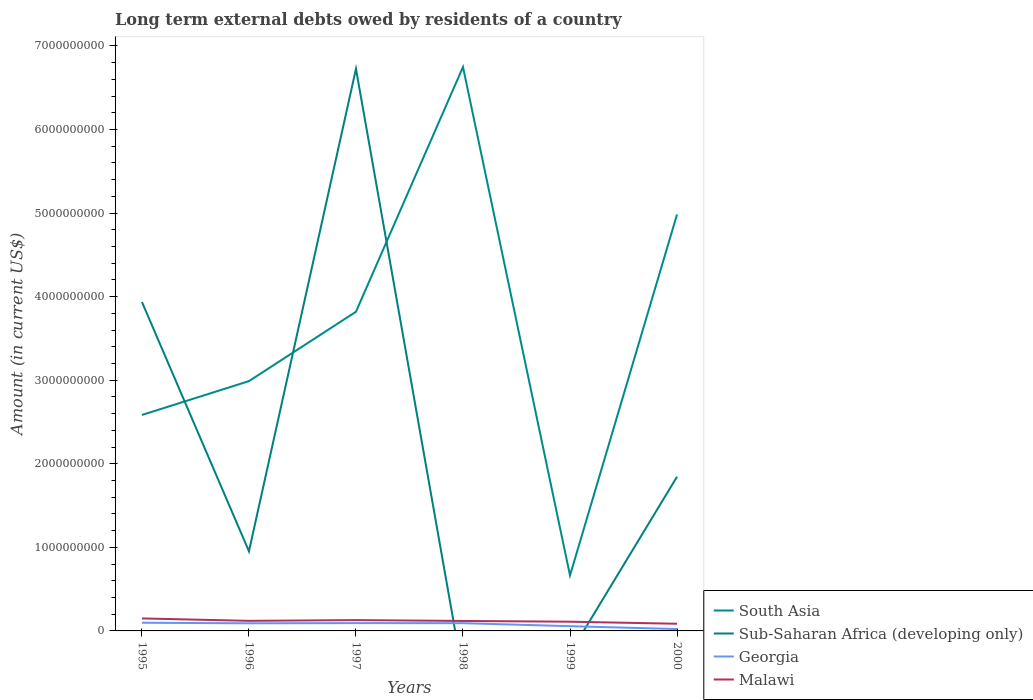How many different coloured lines are there?
Offer a very short reply. 4. Does the line corresponding to Malawi intersect with the line corresponding to Sub-Saharan Africa (developing only)?
Make the answer very short. Yes. Across all years, what is the maximum amount of long-term external debts owed by residents in Malawi?
Ensure brevity in your answer.  8.58e+07. What is the total amount of long-term external debts owed by residents in South Asia in the graph?
Ensure brevity in your answer.  -1.23e+09. What is the difference between the highest and the second highest amount of long-term external debts owed by residents in Georgia?
Your answer should be compact. 7.54e+07. What is the difference between the highest and the lowest amount of long-term external debts owed by residents in Malawi?
Provide a short and direct response. 4. How many lines are there?
Give a very brief answer. 4. How many years are there in the graph?
Give a very brief answer. 6. What is the difference between two consecutive major ticks on the Y-axis?
Your answer should be compact. 1.00e+09. Are the values on the major ticks of Y-axis written in scientific E-notation?
Provide a short and direct response. No. Where does the legend appear in the graph?
Offer a very short reply. Bottom right. How many legend labels are there?
Ensure brevity in your answer.  4. What is the title of the graph?
Keep it short and to the point. Long term external debts owed by residents of a country. What is the label or title of the X-axis?
Provide a succinct answer. Years. What is the label or title of the Y-axis?
Your response must be concise. Amount (in current US$). What is the Amount (in current US$) of South Asia in 1995?
Keep it short and to the point. 2.58e+09. What is the Amount (in current US$) of Sub-Saharan Africa (developing only) in 1995?
Your answer should be very brief. 3.94e+09. What is the Amount (in current US$) of Georgia in 1995?
Make the answer very short. 9.79e+07. What is the Amount (in current US$) in Malawi in 1995?
Your answer should be very brief. 1.50e+08. What is the Amount (in current US$) in South Asia in 1996?
Your response must be concise. 2.99e+09. What is the Amount (in current US$) of Sub-Saharan Africa (developing only) in 1996?
Keep it short and to the point. 9.53e+08. What is the Amount (in current US$) in Georgia in 1996?
Make the answer very short. 9.11e+07. What is the Amount (in current US$) of Malawi in 1996?
Keep it short and to the point. 1.21e+08. What is the Amount (in current US$) in South Asia in 1997?
Make the answer very short. 3.82e+09. What is the Amount (in current US$) of Sub-Saharan Africa (developing only) in 1997?
Keep it short and to the point. 6.73e+09. What is the Amount (in current US$) in Georgia in 1997?
Give a very brief answer. 9.36e+07. What is the Amount (in current US$) in Malawi in 1997?
Provide a succinct answer. 1.30e+08. What is the Amount (in current US$) in South Asia in 1998?
Give a very brief answer. 6.75e+09. What is the Amount (in current US$) of Sub-Saharan Africa (developing only) in 1998?
Keep it short and to the point. 0. What is the Amount (in current US$) in Georgia in 1998?
Provide a short and direct response. 9.25e+07. What is the Amount (in current US$) of Malawi in 1998?
Offer a very short reply. 1.19e+08. What is the Amount (in current US$) in South Asia in 1999?
Provide a short and direct response. 6.64e+08. What is the Amount (in current US$) in Georgia in 1999?
Provide a succinct answer. 5.68e+07. What is the Amount (in current US$) of Malawi in 1999?
Make the answer very short. 1.10e+08. What is the Amount (in current US$) in South Asia in 2000?
Provide a short and direct response. 4.98e+09. What is the Amount (in current US$) in Sub-Saharan Africa (developing only) in 2000?
Provide a succinct answer. 1.84e+09. What is the Amount (in current US$) of Georgia in 2000?
Make the answer very short. 2.25e+07. What is the Amount (in current US$) of Malawi in 2000?
Make the answer very short. 8.58e+07. Across all years, what is the maximum Amount (in current US$) of South Asia?
Ensure brevity in your answer.  6.75e+09. Across all years, what is the maximum Amount (in current US$) of Sub-Saharan Africa (developing only)?
Your response must be concise. 6.73e+09. Across all years, what is the maximum Amount (in current US$) in Georgia?
Make the answer very short. 9.79e+07. Across all years, what is the maximum Amount (in current US$) in Malawi?
Offer a terse response. 1.50e+08. Across all years, what is the minimum Amount (in current US$) in South Asia?
Offer a terse response. 6.64e+08. Across all years, what is the minimum Amount (in current US$) in Sub-Saharan Africa (developing only)?
Ensure brevity in your answer.  0. Across all years, what is the minimum Amount (in current US$) in Georgia?
Your response must be concise. 2.25e+07. Across all years, what is the minimum Amount (in current US$) of Malawi?
Provide a succinct answer. 8.58e+07. What is the total Amount (in current US$) of South Asia in the graph?
Ensure brevity in your answer.  2.18e+1. What is the total Amount (in current US$) of Sub-Saharan Africa (developing only) in the graph?
Provide a succinct answer. 1.35e+1. What is the total Amount (in current US$) in Georgia in the graph?
Keep it short and to the point. 4.54e+08. What is the total Amount (in current US$) in Malawi in the graph?
Offer a very short reply. 7.15e+08. What is the difference between the Amount (in current US$) of South Asia in 1995 and that in 1996?
Make the answer very short. -4.05e+08. What is the difference between the Amount (in current US$) of Sub-Saharan Africa (developing only) in 1995 and that in 1996?
Offer a very short reply. 2.98e+09. What is the difference between the Amount (in current US$) of Georgia in 1995 and that in 1996?
Provide a short and direct response. 6.79e+06. What is the difference between the Amount (in current US$) in Malawi in 1995 and that in 1996?
Offer a terse response. 2.90e+07. What is the difference between the Amount (in current US$) in South Asia in 1995 and that in 1997?
Provide a succinct answer. -1.23e+09. What is the difference between the Amount (in current US$) of Sub-Saharan Africa (developing only) in 1995 and that in 1997?
Give a very brief answer. -2.79e+09. What is the difference between the Amount (in current US$) in Georgia in 1995 and that in 1997?
Provide a short and direct response. 4.30e+06. What is the difference between the Amount (in current US$) of Malawi in 1995 and that in 1997?
Make the answer very short. 2.00e+07. What is the difference between the Amount (in current US$) of South Asia in 1995 and that in 1998?
Give a very brief answer. -4.16e+09. What is the difference between the Amount (in current US$) of Georgia in 1995 and that in 1998?
Keep it short and to the point. 5.34e+06. What is the difference between the Amount (in current US$) of Malawi in 1995 and that in 1998?
Give a very brief answer. 3.04e+07. What is the difference between the Amount (in current US$) of South Asia in 1995 and that in 1999?
Offer a terse response. 1.92e+09. What is the difference between the Amount (in current US$) of Georgia in 1995 and that in 1999?
Your answer should be very brief. 4.11e+07. What is the difference between the Amount (in current US$) in Malawi in 1995 and that in 1999?
Provide a succinct answer. 3.93e+07. What is the difference between the Amount (in current US$) of South Asia in 1995 and that in 2000?
Keep it short and to the point. -2.40e+09. What is the difference between the Amount (in current US$) of Sub-Saharan Africa (developing only) in 1995 and that in 2000?
Provide a short and direct response. 2.09e+09. What is the difference between the Amount (in current US$) in Georgia in 1995 and that in 2000?
Your answer should be very brief. 7.54e+07. What is the difference between the Amount (in current US$) in Malawi in 1995 and that in 2000?
Your response must be concise. 6.38e+07. What is the difference between the Amount (in current US$) of South Asia in 1996 and that in 1997?
Make the answer very short. -8.30e+08. What is the difference between the Amount (in current US$) of Sub-Saharan Africa (developing only) in 1996 and that in 1997?
Your answer should be very brief. -5.77e+09. What is the difference between the Amount (in current US$) in Georgia in 1996 and that in 1997?
Your answer should be compact. -2.48e+06. What is the difference between the Amount (in current US$) of Malawi in 1996 and that in 1997?
Your answer should be compact. -8.96e+06. What is the difference between the Amount (in current US$) of South Asia in 1996 and that in 1998?
Provide a short and direct response. -3.76e+09. What is the difference between the Amount (in current US$) of Georgia in 1996 and that in 1998?
Make the answer very short. -1.45e+06. What is the difference between the Amount (in current US$) of Malawi in 1996 and that in 1998?
Your answer should be very brief. 1.41e+06. What is the difference between the Amount (in current US$) of South Asia in 1996 and that in 1999?
Give a very brief answer. 2.33e+09. What is the difference between the Amount (in current US$) in Georgia in 1996 and that in 1999?
Offer a terse response. 3.43e+07. What is the difference between the Amount (in current US$) in Malawi in 1996 and that in 1999?
Offer a terse response. 1.03e+07. What is the difference between the Amount (in current US$) in South Asia in 1996 and that in 2000?
Provide a succinct answer. -1.99e+09. What is the difference between the Amount (in current US$) in Sub-Saharan Africa (developing only) in 1996 and that in 2000?
Offer a terse response. -8.92e+08. What is the difference between the Amount (in current US$) in Georgia in 1996 and that in 2000?
Your response must be concise. 6.86e+07. What is the difference between the Amount (in current US$) of Malawi in 1996 and that in 2000?
Provide a short and direct response. 3.48e+07. What is the difference between the Amount (in current US$) of South Asia in 1997 and that in 1998?
Your answer should be very brief. -2.93e+09. What is the difference between the Amount (in current US$) of Georgia in 1997 and that in 1998?
Your answer should be compact. 1.04e+06. What is the difference between the Amount (in current US$) in Malawi in 1997 and that in 1998?
Ensure brevity in your answer.  1.04e+07. What is the difference between the Amount (in current US$) in South Asia in 1997 and that in 1999?
Give a very brief answer. 3.16e+09. What is the difference between the Amount (in current US$) of Georgia in 1997 and that in 1999?
Keep it short and to the point. 3.68e+07. What is the difference between the Amount (in current US$) of Malawi in 1997 and that in 1999?
Provide a short and direct response. 1.93e+07. What is the difference between the Amount (in current US$) in South Asia in 1997 and that in 2000?
Offer a very short reply. -1.16e+09. What is the difference between the Amount (in current US$) of Sub-Saharan Africa (developing only) in 1997 and that in 2000?
Provide a short and direct response. 4.88e+09. What is the difference between the Amount (in current US$) in Georgia in 1997 and that in 2000?
Your answer should be compact. 7.11e+07. What is the difference between the Amount (in current US$) in Malawi in 1997 and that in 2000?
Provide a succinct answer. 4.38e+07. What is the difference between the Amount (in current US$) of South Asia in 1998 and that in 1999?
Provide a short and direct response. 6.08e+09. What is the difference between the Amount (in current US$) in Georgia in 1998 and that in 1999?
Your response must be concise. 3.58e+07. What is the difference between the Amount (in current US$) of Malawi in 1998 and that in 1999?
Offer a very short reply. 8.88e+06. What is the difference between the Amount (in current US$) in South Asia in 1998 and that in 2000?
Your answer should be very brief. 1.76e+09. What is the difference between the Amount (in current US$) of Georgia in 1998 and that in 2000?
Your answer should be compact. 7.00e+07. What is the difference between the Amount (in current US$) in Malawi in 1998 and that in 2000?
Your response must be concise. 3.34e+07. What is the difference between the Amount (in current US$) of South Asia in 1999 and that in 2000?
Your answer should be very brief. -4.32e+09. What is the difference between the Amount (in current US$) in Georgia in 1999 and that in 2000?
Your answer should be very brief. 3.43e+07. What is the difference between the Amount (in current US$) of Malawi in 1999 and that in 2000?
Your response must be concise. 2.46e+07. What is the difference between the Amount (in current US$) in South Asia in 1995 and the Amount (in current US$) in Sub-Saharan Africa (developing only) in 1996?
Make the answer very short. 1.63e+09. What is the difference between the Amount (in current US$) of South Asia in 1995 and the Amount (in current US$) of Georgia in 1996?
Offer a terse response. 2.49e+09. What is the difference between the Amount (in current US$) of South Asia in 1995 and the Amount (in current US$) of Malawi in 1996?
Make the answer very short. 2.46e+09. What is the difference between the Amount (in current US$) in Sub-Saharan Africa (developing only) in 1995 and the Amount (in current US$) in Georgia in 1996?
Provide a succinct answer. 3.85e+09. What is the difference between the Amount (in current US$) of Sub-Saharan Africa (developing only) in 1995 and the Amount (in current US$) of Malawi in 1996?
Offer a terse response. 3.82e+09. What is the difference between the Amount (in current US$) in Georgia in 1995 and the Amount (in current US$) in Malawi in 1996?
Provide a short and direct response. -2.28e+07. What is the difference between the Amount (in current US$) in South Asia in 1995 and the Amount (in current US$) in Sub-Saharan Africa (developing only) in 1997?
Offer a very short reply. -4.14e+09. What is the difference between the Amount (in current US$) of South Asia in 1995 and the Amount (in current US$) of Georgia in 1997?
Your response must be concise. 2.49e+09. What is the difference between the Amount (in current US$) of South Asia in 1995 and the Amount (in current US$) of Malawi in 1997?
Keep it short and to the point. 2.45e+09. What is the difference between the Amount (in current US$) of Sub-Saharan Africa (developing only) in 1995 and the Amount (in current US$) of Georgia in 1997?
Offer a very short reply. 3.84e+09. What is the difference between the Amount (in current US$) in Sub-Saharan Africa (developing only) in 1995 and the Amount (in current US$) in Malawi in 1997?
Your answer should be compact. 3.81e+09. What is the difference between the Amount (in current US$) in Georgia in 1995 and the Amount (in current US$) in Malawi in 1997?
Keep it short and to the point. -3.17e+07. What is the difference between the Amount (in current US$) in South Asia in 1995 and the Amount (in current US$) in Georgia in 1998?
Provide a short and direct response. 2.49e+09. What is the difference between the Amount (in current US$) in South Asia in 1995 and the Amount (in current US$) in Malawi in 1998?
Ensure brevity in your answer.  2.46e+09. What is the difference between the Amount (in current US$) in Sub-Saharan Africa (developing only) in 1995 and the Amount (in current US$) in Georgia in 1998?
Make the answer very short. 3.84e+09. What is the difference between the Amount (in current US$) in Sub-Saharan Africa (developing only) in 1995 and the Amount (in current US$) in Malawi in 1998?
Ensure brevity in your answer.  3.82e+09. What is the difference between the Amount (in current US$) in Georgia in 1995 and the Amount (in current US$) in Malawi in 1998?
Provide a succinct answer. -2.14e+07. What is the difference between the Amount (in current US$) in South Asia in 1995 and the Amount (in current US$) in Georgia in 1999?
Provide a succinct answer. 2.53e+09. What is the difference between the Amount (in current US$) in South Asia in 1995 and the Amount (in current US$) in Malawi in 1999?
Your answer should be compact. 2.47e+09. What is the difference between the Amount (in current US$) in Sub-Saharan Africa (developing only) in 1995 and the Amount (in current US$) in Georgia in 1999?
Provide a short and direct response. 3.88e+09. What is the difference between the Amount (in current US$) of Sub-Saharan Africa (developing only) in 1995 and the Amount (in current US$) of Malawi in 1999?
Offer a terse response. 3.83e+09. What is the difference between the Amount (in current US$) in Georgia in 1995 and the Amount (in current US$) in Malawi in 1999?
Provide a succinct answer. -1.25e+07. What is the difference between the Amount (in current US$) of South Asia in 1995 and the Amount (in current US$) of Sub-Saharan Africa (developing only) in 2000?
Keep it short and to the point. 7.39e+08. What is the difference between the Amount (in current US$) of South Asia in 1995 and the Amount (in current US$) of Georgia in 2000?
Offer a very short reply. 2.56e+09. What is the difference between the Amount (in current US$) in South Asia in 1995 and the Amount (in current US$) in Malawi in 2000?
Keep it short and to the point. 2.50e+09. What is the difference between the Amount (in current US$) in Sub-Saharan Africa (developing only) in 1995 and the Amount (in current US$) in Georgia in 2000?
Make the answer very short. 3.91e+09. What is the difference between the Amount (in current US$) of Sub-Saharan Africa (developing only) in 1995 and the Amount (in current US$) of Malawi in 2000?
Give a very brief answer. 3.85e+09. What is the difference between the Amount (in current US$) of Georgia in 1995 and the Amount (in current US$) of Malawi in 2000?
Keep it short and to the point. 1.21e+07. What is the difference between the Amount (in current US$) in South Asia in 1996 and the Amount (in current US$) in Sub-Saharan Africa (developing only) in 1997?
Provide a succinct answer. -3.74e+09. What is the difference between the Amount (in current US$) in South Asia in 1996 and the Amount (in current US$) in Georgia in 1997?
Ensure brevity in your answer.  2.90e+09. What is the difference between the Amount (in current US$) of South Asia in 1996 and the Amount (in current US$) of Malawi in 1997?
Provide a succinct answer. 2.86e+09. What is the difference between the Amount (in current US$) in Sub-Saharan Africa (developing only) in 1996 and the Amount (in current US$) in Georgia in 1997?
Provide a succinct answer. 8.59e+08. What is the difference between the Amount (in current US$) of Sub-Saharan Africa (developing only) in 1996 and the Amount (in current US$) of Malawi in 1997?
Offer a very short reply. 8.23e+08. What is the difference between the Amount (in current US$) of Georgia in 1996 and the Amount (in current US$) of Malawi in 1997?
Offer a terse response. -3.85e+07. What is the difference between the Amount (in current US$) in South Asia in 1996 and the Amount (in current US$) in Georgia in 1998?
Your answer should be very brief. 2.90e+09. What is the difference between the Amount (in current US$) of South Asia in 1996 and the Amount (in current US$) of Malawi in 1998?
Your response must be concise. 2.87e+09. What is the difference between the Amount (in current US$) of Sub-Saharan Africa (developing only) in 1996 and the Amount (in current US$) of Georgia in 1998?
Make the answer very short. 8.60e+08. What is the difference between the Amount (in current US$) in Sub-Saharan Africa (developing only) in 1996 and the Amount (in current US$) in Malawi in 1998?
Give a very brief answer. 8.34e+08. What is the difference between the Amount (in current US$) in Georgia in 1996 and the Amount (in current US$) in Malawi in 1998?
Offer a terse response. -2.82e+07. What is the difference between the Amount (in current US$) of South Asia in 1996 and the Amount (in current US$) of Georgia in 1999?
Ensure brevity in your answer.  2.93e+09. What is the difference between the Amount (in current US$) in South Asia in 1996 and the Amount (in current US$) in Malawi in 1999?
Give a very brief answer. 2.88e+09. What is the difference between the Amount (in current US$) of Sub-Saharan Africa (developing only) in 1996 and the Amount (in current US$) of Georgia in 1999?
Ensure brevity in your answer.  8.96e+08. What is the difference between the Amount (in current US$) of Sub-Saharan Africa (developing only) in 1996 and the Amount (in current US$) of Malawi in 1999?
Give a very brief answer. 8.43e+08. What is the difference between the Amount (in current US$) in Georgia in 1996 and the Amount (in current US$) in Malawi in 1999?
Your answer should be compact. -1.93e+07. What is the difference between the Amount (in current US$) in South Asia in 1996 and the Amount (in current US$) in Sub-Saharan Africa (developing only) in 2000?
Keep it short and to the point. 1.14e+09. What is the difference between the Amount (in current US$) in South Asia in 1996 and the Amount (in current US$) in Georgia in 2000?
Give a very brief answer. 2.97e+09. What is the difference between the Amount (in current US$) in South Asia in 1996 and the Amount (in current US$) in Malawi in 2000?
Provide a short and direct response. 2.90e+09. What is the difference between the Amount (in current US$) in Sub-Saharan Africa (developing only) in 1996 and the Amount (in current US$) in Georgia in 2000?
Offer a very short reply. 9.30e+08. What is the difference between the Amount (in current US$) in Sub-Saharan Africa (developing only) in 1996 and the Amount (in current US$) in Malawi in 2000?
Ensure brevity in your answer.  8.67e+08. What is the difference between the Amount (in current US$) of Georgia in 1996 and the Amount (in current US$) of Malawi in 2000?
Your answer should be very brief. 5.28e+06. What is the difference between the Amount (in current US$) of South Asia in 1997 and the Amount (in current US$) of Georgia in 1998?
Your answer should be very brief. 3.73e+09. What is the difference between the Amount (in current US$) in South Asia in 1997 and the Amount (in current US$) in Malawi in 1998?
Give a very brief answer. 3.70e+09. What is the difference between the Amount (in current US$) of Sub-Saharan Africa (developing only) in 1997 and the Amount (in current US$) of Georgia in 1998?
Your response must be concise. 6.63e+09. What is the difference between the Amount (in current US$) in Sub-Saharan Africa (developing only) in 1997 and the Amount (in current US$) in Malawi in 1998?
Your answer should be compact. 6.61e+09. What is the difference between the Amount (in current US$) in Georgia in 1997 and the Amount (in current US$) in Malawi in 1998?
Your answer should be compact. -2.57e+07. What is the difference between the Amount (in current US$) in South Asia in 1997 and the Amount (in current US$) in Georgia in 1999?
Give a very brief answer. 3.76e+09. What is the difference between the Amount (in current US$) in South Asia in 1997 and the Amount (in current US$) in Malawi in 1999?
Keep it short and to the point. 3.71e+09. What is the difference between the Amount (in current US$) of Sub-Saharan Africa (developing only) in 1997 and the Amount (in current US$) of Georgia in 1999?
Give a very brief answer. 6.67e+09. What is the difference between the Amount (in current US$) in Sub-Saharan Africa (developing only) in 1997 and the Amount (in current US$) in Malawi in 1999?
Provide a short and direct response. 6.62e+09. What is the difference between the Amount (in current US$) of Georgia in 1997 and the Amount (in current US$) of Malawi in 1999?
Provide a short and direct response. -1.68e+07. What is the difference between the Amount (in current US$) of South Asia in 1997 and the Amount (in current US$) of Sub-Saharan Africa (developing only) in 2000?
Your response must be concise. 1.97e+09. What is the difference between the Amount (in current US$) of South Asia in 1997 and the Amount (in current US$) of Georgia in 2000?
Offer a very short reply. 3.80e+09. What is the difference between the Amount (in current US$) in South Asia in 1997 and the Amount (in current US$) in Malawi in 2000?
Your response must be concise. 3.73e+09. What is the difference between the Amount (in current US$) in Sub-Saharan Africa (developing only) in 1997 and the Amount (in current US$) in Georgia in 2000?
Offer a terse response. 6.70e+09. What is the difference between the Amount (in current US$) of Sub-Saharan Africa (developing only) in 1997 and the Amount (in current US$) of Malawi in 2000?
Give a very brief answer. 6.64e+09. What is the difference between the Amount (in current US$) of Georgia in 1997 and the Amount (in current US$) of Malawi in 2000?
Ensure brevity in your answer.  7.76e+06. What is the difference between the Amount (in current US$) of South Asia in 1998 and the Amount (in current US$) of Georgia in 1999?
Provide a short and direct response. 6.69e+09. What is the difference between the Amount (in current US$) in South Asia in 1998 and the Amount (in current US$) in Malawi in 1999?
Give a very brief answer. 6.64e+09. What is the difference between the Amount (in current US$) of Georgia in 1998 and the Amount (in current US$) of Malawi in 1999?
Your answer should be very brief. -1.78e+07. What is the difference between the Amount (in current US$) in South Asia in 1998 and the Amount (in current US$) in Sub-Saharan Africa (developing only) in 2000?
Give a very brief answer. 4.90e+09. What is the difference between the Amount (in current US$) in South Asia in 1998 and the Amount (in current US$) in Georgia in 2000?
Ensure brevity in your answer.  6.73e+09. What is the difference between the Amount (in current US$) in South Asia in 1998 and the Amount (in current US$) in Malawi in 2000?
Provide a short and direct response. 6.66e+09. What is the difference between the Amount (in current US$) in Georgia in 1998 and the Amount (in current US$) in Malawi in 2000?
Your response must be concise. 6.72e+06. What is the difference between the Amount (in current US$) in South Asia in 1999 and the Amount (in current US$) in Sub-Saharan Africa (developing only) in 2000?
Keep it short and to the point. -1.18e+09. What is the difference between the Amount (in current US$) in South Asia in 1999 and the Amount (in current US$) in Georgia in 2000?
Your response must be concise. 6.41e+08. What is the difference between the Amount (in current US$) in South Asia in 1999 and the Amount (in current US$) in Malawi in 2000?
Provide a succinct answer. 5.78e+08. What is the difference between the Amount (in current US$) in Georgia in 1999 and the Amount (in current US$) in Malawi in 2000?
Keep it short and to the point. -2.90e+07. What is the average Amount (in current US$) in South Asia per year?
Offer a very short reply. 3.63e+09. What is the average Amount (in current US$) in Sub-Saharan Africa (developing only) per year?
Your answer should be compact. 2.24e+09. What is the average Amount (in current US$) in Georgia per year?
Your response must be concise. 7.57e+07. What is the average Amount (in current US$) of Malawi per year?
Give a very brief answer. 1.19e+08. In the year 1995, what is the difference between the Amount (in current US$) in South Asia and Amount (in current US$) in Sub-Saharan Africa (developing only)?
Your answer should be very brief. -1.35e+09. In the year 1995, what is the difference between the Amount (in current US$) of South Asia and Amount (in current US$) of Georgia?
Offer a very short reply. 2.49e+09. In the year 1995, what is the difference between the Amount (in current US$) of South Asia and Amount (in current US$) of Malawi?
Keep it short and to the point. 2.43e+09. In the year 1995, what is the difference between the Amount (in current US$) of Sub-Saharan Africa (developing only) and Amount (in current US$) of Georgia?
Your answer should be compact. 3.84e+09. In the year 1995, what is the difference between the Amount (in current US$) of Sub-Saharan Africa (developing only) and Amount (in current US$) of Malawi?
Provide a succinct answer. 3.79e+09. In the year 1995, what is the difference between the Amount (in current US$) in Georgia and Amount (in current US$) in Malawi?
Your answer should be compact. -5.18e+07. In the year 1996, what is the difference between the Amount (in current US$) in South Asia and Amount (in current US$) in Sub-Saharan Africa (developing only)?
Make the answer very short. 2.04e+09. In the year 1996, what is the difference between the Amount (in current US$) of South Asia and Amount (in current US$) of Georgia?
Ensure brevity in your answer.  2.90e+09. In the year 1996, what is the difference between the Amount (in current US$) in South Asia and Amount (in current US$) in Malawi?
Your response must be concise. 2.87e+09. In the year 1996, what is the difference between the Amount (in current US$) in Sub-Saharan Africa (developing only) and Amount (in current US$) in Georgia?
Your answer should be very brief. 8.62e+08. In the year 1996, what is the difference between the Amount (in current US$) in Sub-Saharan Africa (developing only) and Amount (in current US$) in Malawi?
Offer a terse response. 8.32e+08. In the year 1996, what is the difference between the Amount (in current US$) in Georgia and Amount (in current US$) in Malawi?
Offer a terse response. -2.96e+07. In the year 1997, what is the difference between the Amount (in current US$) of South Asia and Amount (in current US$) of Sub-Saharan Africa (developing only)?
Offer a very short reply. -2.91e+09. In the year 1997, what is the difference between the Amount (in current US$) of South Asia and Amount (in current US$) of Georgia?
Keep it short and to the point. 3.73e+09. In the year 1997, what is the difference between the Amount (in current US$) in South Asia and Amount (in current US$) in Malawi?
Your response must be concise. 3.69e+09. In the year 1997, what is the difference between the Amount (in current US$) in Sub-Saharan Africa (developing only) and Amount (in current US$) in Georgia?
Your answer should be compact. 6.63e+09. In the year 1997, what is the difference between the Amount (in current US$) in Sub-Saharan Africa (developing only) and Amount (in current US$) in Malawi?
Keep it short and to the point. 6.60e+09. In the year 1997, what is the difference between the Amount (in current US$) of Georgia and Amount (in current US$) of Malawi?
Ensure brevity in your answer.  -3.60e+07. In the year 1998, what is the difference between the Amount (in current US$) in South Asia and Amount (in current US$) in Georgia?
Your answer should be very brief. 6.66e+09. In the year 1998, what is the difference between the Amount (in current US$) of South Asia and Amount (in current US$) of Malawi?
Ensure brevity in your answer.  6.63e+09. In the year 1998, what is the difference between the Amount (in current US$) of Georgia and Amount (in current US$) of Malawi?
Provide a short and direct response. -2.67e+07. In the year 1999, what is the difference between the Amount (in current US$) of South Asia and Amount (in current US$) of Georgia?
Ensure brevity in your answer.  6.07e+08. In the year 1999, what is the difference between the Amount (in current US$) in South Asia and Amount (in current US$) in Malawi?
Keep it short and to the point. 5.53e+08. In the year 1999, what is the difference between the Amount (in current US$) in Georgia and Amount (in current US$) in Malawi?
Give a very brief answer. -5.36e+07. In the year 2000, what is the difference between the Amount (in current US$) of South Asia and Amount (in current US$) of Sub-Saharan Africa (developing only)?
Keep it short and to the point. 3.14e+09. In the year 2000, what is the difference between the Amount (in current US$) of South Asia and Amount (in current US$) of Georgia?
Give a very brief answer. 4.96e+09. In the year 2000, what is the difference between the Amount (in current US$) in South Asia and Amount (in current US$) in Malawi?
Make the answer very short. 4.90e+09. In the year 2000, what is the difference between the Amount (in current US$) of Sub-Saharan Africa (developing only) and Amount (in current US$) of Georgia?
Your response must be concise. 1.82e+09. In the year 2000, what is the difference between the Amount (in current US$) of Sub-Saharan Africa (developing only) and Amount (in current US$) of Malawi?
Make the answer very short. 1.76e+09. In the year 2000, what is the difference between the Amount (in current US$) in Georgia and Amount (in current US$) in Malawi?
Give a very brief answer. -6.33e+07. What is the ratio of the Amount (in current US$) of South Asia in 1995 to that in 1996?
Your answer should be compact. 0.86. What is the ratio of the Amount (in current US$) of Sub-Saharan Africa (developing only) in 1995 to that in 1996?
Make the answer very short. 4.13. What is the ratio of the Amount (in current US$) of Georgia in 1995 to that in 1996?
Provide a short and direct response. 1.07. What is the ratio of the Amount (in current US$) of Malawi in 1995 to that in 1996?
Keep it short and to the point. 1.24. What is the ratio of the Amount (in current US$) of South Asia in 1995 to that in 1997?
Provide a succinct answer. 0.68. What is the ratio of the Amount (in current US$) of Sub-Saharan Africa (developing only) in 1995 to that in 1997?
Your answer should be very brief. 0.59. What is the ratio of the Amount (in current US$) of Georgia in 1995 to that in 1997?
Offer a very short reply. 1.05. What is the ratio of the Amount (in current US$) in Malawi in 1995 to that in 1997?
Make the answer very short. 1.15. What is the ratio of the Amount (in current US$) in South Asia in 1995 to that in 1998?
Offer a terse response. 0.38. What is the ratio of the Amount (in current US$) in Georgia in 1995 to that in 1998?
Provide a succinct answer. 1.06. What is the ratio of the Amount (in current US$) of Malawi in 1995 to that in 1998?
Offer a very short reply. 1.25. What is the ratio of the Amount (in current US$) in South Asia in 1995 to that in 1999?
Your answer should be very brief. 3.89. What is the ratio of the Amount (in current US$) of Georgia in 1995 to that in 1999?
Provide a short and direct response. 1.72. What is the ratio of the Amount (in current US$) in Malawi in 1995 to that in 1999?
Your answer should be compact. 1.36. What is the ratio of the Amount (in current US$) in South Asia in 1995 to that in 2000?
Your answer should be compact. 0.52. What is the ratio of the Amount (in current US$) in Sub-Saharan Africa (developing only) in 1995 to that in 2000?
Give a very brief answer. 2.13. What is the ratio of the Amount (in current US$) of Georgia in 1995 to that in 2000?
Your answer should be very brief. 4.35. What is the ratio of the Amount (in current US$) in Malawi in 1995 to that in 2000?
Ensure brevity in your answer.  1.74. What is the ratio of the Amount (in current US$) of South Asia in 1996 to that in 1997?
Ensure brevity in your answer.  0.78. What is the ratio of the Amount (in current US$) of Sub-Saharan Africa (developing only) in 1996 to that in 1997?
Offer a very short reply. 0.14. What is the ratio of the Amount (in current US$) in Georgia in 1996 to that in 1997?
Give a very brief answer. 0.97. What is the ratio of the Amount (in current US$) of Malawi in 1996 to that in 1997?
Offer a very short reply. 0.93. What is the ratio of the Amount (in current US$) in South Asia in 1996 to that in 1998?
Your response must be concise. 0.44. What is the ratio of the Amount (in current US$) of Georgia in 1996 to that in 1998?
Offer a very short reply. 0.98. What is the ratio of the Amount (in current US$) of Malawi in 1996 to that in 1998?
Ensure brevity in your answer.  1.01. What is the ratio of the Amount (in current US$) of South Asia in 1996 to that in 1999?
Provide a short and direct response. 4.5. What is the ratio of the Amount (in current US$) in Georgia in 1996 to that in 1999?
Your response must be concise. 1.6. What is the ratio of the Amount (in current US$) in Malawi in 1996 to that in 1999?
Keep it short and to the point. 1.09. What is the ratio of the Amount (in current US$) of South Asia in 1996 to that in 2000?
Give a very brief answer. 0.6. What is the ratio of the Amount (in current US$) in Sub-Saharan Africa (developing only) in 1996 to that in 2000?
Your response must be concise. 0.52. What is the ratio of the Amount (in current US$) in Georgia in 1996 to that in 2000?
Make the answer very short. 4.05. What is the ratio of the Amount (in current US$) of Malawi in 1996 to that in 2000?
Your response must be concise. 1.41. What is the ratio of the Amount (in current US$) of South Asia in 1997 to that in 1998?
Your answer should be very brief. 0.57. What is the ratio of the Amount (in current US$) of Georgia in 1997 to that in 1998?
Provide a succinct answer. 1.01. What is the ratio of the Amount (in current US$) of Malawi in 1997 to that in 1998?
Provide a short and direct response. 1.09. What is the ratio of the Amount (in current US$) in South Asia in 1997 to that in 1999?
Provide a succinct answer. 5.75. What is the ratio of the Amount (in current US$) in Georgia in 1997 to that in 1999?
Your answer should be very brief. 1.65. What is the ratio of the Amount (in current US$) of Malawi in 1997 to that in 1999?
Your answer should be very brief. 1.17. What is the ratio of the Amount (in current US$) in South Asia in 1997 to that in 2000?
Offer a very short reply. 0.77. What is the ratio of the Amount (in current US$) in Sub-Saharan Africa (developing only) in 1997 to that in 2000?
Offer a very short reply. 3.65. What is the ratio of the Amount (in current US$) in Georgia in 1997 to that in 2000?
Offer a terse response. 4.16. What is the ratio of the Amount (in current US$) of Malawi in 1997 to that in 2000?
Your response must be concise. 1.51. What is the ratio of the Amount (in current US$) of South Asia in 1998 to that in 1999?
Offer a very short reply. 10.17. What is the ratio of the Amount (in current US$) in Georgia in 1998 to that in 1999?
Make the answer very short. 1.63. What is the ratio of the Amount (in current US$) in Malawi in 1998 to that in 1999?
Give a very brief answer. 1.08. What is the ratio of the Amount (in current US$) of South Asia in 1998 to that in 2000?
Offer a very short reply. 1.35. What is the ratio of the Amount (in current US$) of Georgia in 1998 to that in 2000?
Provide a succinct answer. 4.11. What is the ratio of the Amount (in current US$) of Malawi in 1998 to that in 2000?
Make the answer very short. 1.39. What is the ratio of the Amount (in current US$) of South Asia in 1999 to that in 2000?
Ensure brevity in your answer.  0.13. What is the ratio of the Amount (in current US$) of Georgia in 1999 to that in 2000?
Your response must be concise. 2.52. What is the ratio of the Amount (in current US$) of Malawi in 1999 to that in 2000?
Keep it short and to the point. 1.29. What is the difference between the highest and the second highest Amount (in current US$) in South Asia?
Your answer should be very brief. 1.76e+09. What is the difference between the highest and the second highest Amount (in current US$) of Sub-Saharan Africa (developing only)?
Keep it short and to the point. 2.79e+09. What is the difference between the highest and the second highest Amount (in current US$) of Georgia?
Keep it short and to the point. 4.30e+06. What is the difference between the highest and the second highest Amount (in current US$) in Malawi?
Offer a terse response. 2.00e+07. What is the difference between the highest and the lowest Amount (in current US$) in South Asia?
Make the answer very short. 6.08e+09. What is the difference between the highest and the lowest Amount (in current US$) of Sub-Saharan Africa (developing only)?
Your answer should be very brief. 6.73e+09. What is the difference between the highest and the lowest Amount (in current US$) of Georgia?
Give a very brief answer. 7.54e+07. What is the difference between the highest and the lowest Amount (in current US$) of Malawi?
Ensure brevity in your answer.  6.38e+07. 